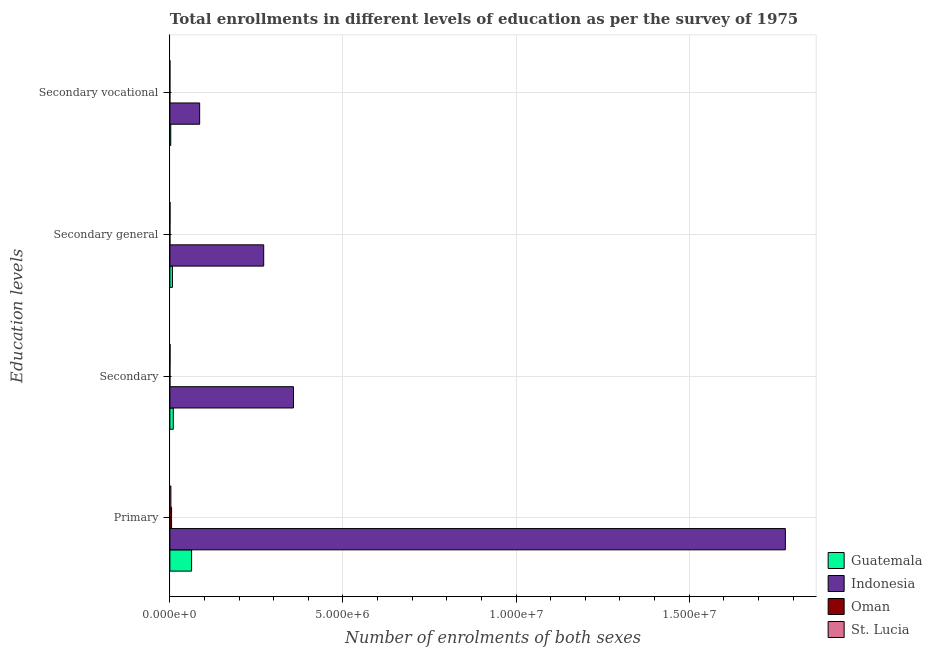How many different coloured bars are there?
Keep it short and to the point. 4. How many groups of bars are there?
Provide a succinct answer. 4. Are the number of bars per tick equal to the number of legend labels?
Make the answer very short. Yes. Are the number of bars on each tick of the Y-axis equal?
Your response must be concise. Yes. How many bars are there on the 1st tick from the top?
Your response must be concise. 4. What is the label of the 1st group of bars from the top?
Your answer should be very brief. Secondary vocational. What is the number of enrolments in secondary education in St. Lucia?
Provide a succinct answer. 4579. Across all countries, what is the maximum number of enrolments in secondary general education?
Give a very brief answer. 2.71e+06. Across all countries, what is the minimum number of enrolments in secondary vocational education?
Provide a short and direct response. 70. In which country was the number of enrolments in primary education maximum?
Your response must be concise. Indonesia. In which country was the number of enrolments in secondary vocational education minimum?
Offer a terse response. Oman. What is the total number of enrolments in primary education in the graph?
Provide a succinct answer. 1.85e+07. What is the difference between the number of enrolments in secondary general education in St. Lucia and that in Indonesia?
Keep it short and to the point. -2.71e+06. What is the difference between the number of enrolments in secondary education in Oman and the number of enrolments in secondary general education in Indonesia?
Give a very brief answer. -2.71e+06. What is the average number of enrolments in secondary education per country?
Give a very brief answer. 9.19e+05. What is the difference between the number of enrolments in secondary education and number of enrolments in secondary general education in Oman?
Provide a short and direct response. 70. In how many countries, is the number of enrolments in secondary vocational education greater than 15000000 ?
Ensure brevity in your answer.  0. What is the ratio of the number of enrolments in secondary education in Indonesia to that in Guatemala?
Ensure brevity in your answer.  35.98. What is the difference between the highest and the second highest number of enrolments in secondary vocational education?
Your response must be concise. 8.35e+05. What is the difference between the highest and the lowest number of enrolments in secondary vocational education?
Offer a terse response. 8.60e+05. In how many countries, is the number of enrolments in secondary education greater than the average number of enrolments in secondary education taken over all countries?
Give a very brief answer. 1. What does the 2nd bar from the top in Secondary vocational represents?
Offer a terse response. Oman. What does the 1st bar from the bottom in Secondary general represents?
Your response must be concise. Guatemala. How many bars are there?
Offer a very short reply. 16. Are all the bars in the graph horizontal?
Ensure brevity in your answer.  Yes. How many countries are there in the graph?
Keep it short and to the point. 4. What is the difference between two consecutive major ticks on the X-axis?
Ensure brevity in your answer.  5.00e+06. Are the values on the major ticks of X-axis written in scientific E-notation?
Provide a short and direct response. Yes. Does the graph contain any zero values?
Offer a very short reply. No. Does the graph contain grids?
Keep it short and to the point. Yes. Where does the legend appear in the graph?
Your answer should be very brief. Bottom right. How are the legend labels stacked?
Provide a succinct answer. Vertical. What is the title of the graph?
Offer a very short reply. Total enrollments in different levels of education as per the survey of 1975. What is the label or title of the X-axis?
Make the answer very short. Number of enrolments of both sexes. What is the label or title of the Y-axis?
Make the answer very short. Education levels. What is the Number of enrolments of both sexes of Guatemala in Primary?
Your answer should be very brief. 6.27e+05. What is the Number of enrolments of both sexes in Indonesia in Primary?
Your answer should be very brief. 1.78e+07. What is the Number of enrolments of both sexes of Oman in Primary?
Provide a short and direct response. 4.86e+04. What is the Number of enrolments of both sexes of St. Lucia in Primary?
Provide a short and direct response. 2.91e+04. What is the Number of enrolments of both sexes in Guatemala in Secondary?
Your answer should be compact. 9.92e+04. What is the Number of enrolments of both sexes of Indonesia in Secondary?
Give a very brief answer. 3.57e+06. What is the Number of enrolments of both sexes in Oman in Secondary?
Your answer should be compact. 723. What is the Number of enrolments of both sexes of St. Lucia in Secondary?
Keep it short and to the point. 4579. What is the Number of enrolments of both sexes of Guatemala in Secondary general?
Ensure brevity in your answer.  7.39e+04. What is the Number of enrolments of both sexes of Indonesia in Secondary general?
Your answer should be very brief. 2.71e+06. What is the Number of enrolments of both sexes of Oman in Secondary general?
Provide a succinct answer. 653. What is the Number of enrolments of both sexes in St. Lucia in Secondary general?
Your response must be concise. 4181. What is the Number of enrolments of both sexes in Guatemala in Secondary vocational?
Your response must be concise. 2.53e+04. What is the Number of enrolments of both sexes of Indonesia in Secondary vocational?
Provide a succinct answer. 8.60e+05. What is the Number of enrolments of both sexes of St. Lucia in Secondary vocational?
Ensure brevity in your answer.  398. Across all Education levels, what is the maximum Number of enrolments of both sexes of Guatemala?
Offer a very short reply. 6.27e+05. Across all Education levels, what is the maximum Number of enrolments of both sexes of Indonesia?
Ensure brevity in your answer.  1.78e+07. Across all Education levels, what is the maximum Number of enrolments of both sexes in Oman?
Provide a short and direct response. 4.86e+04. Across all Education levels, what is the maximum Number of enrolments of both sexes in St. Lucia?
Your answer should be very brief. 2.91e+04. Across all Education levels, what is the minimum Number of enrolments of both sexes of Guatemala?
Ensure brevity in your answer.  2.53e+04. Across all Education levels, what is the minimum Number of enrolments of both sexes of Indonesia?
Ensure brevity in your answer.  8.60e+05. Across all Education levels, what is the minimum Number of enrolments of both sexes in Oman?
Keep it short and to the point. 70. Across all Education levels, what is the minimum Number of enrolments of both sexes of St. Lucia?
Your answer should be very brief. 398. What is the total Number of enrolments of both sexes of Guatemala in the graph?
Provide a short and direct response. 8.26e+05. What is the total Number of enrolments of both sexes of Indonesia in the graph?
Ensure brevity in your answer.  2.49e+07. What is the total Number of enrolments of both sexes in Oman in the graph?
Make the answer very short. 5.01e+04. What is the total Number of enrolments of both sexes in St. Lucia in the graph?
Give a very brief answer. 3.82e+04. What is the difference between the Number of enrolments of both sexes of Guatemala in Primary and that in Secondary?
Provide a short and direct response. 5.28e+05. What is the difference between the Number of enrolments of both sexes in Indonesia in Primary and that in Secondary?
Ensure brevity in your answer.  1.42e+07. What is the difference between the Number of enrolments of both sexes in Oman in Primary and that in Secondary?
Give a very brief answer. 4.79e+04. What is the difference between the Number of enrolments of both sexes in St. Lucia in Primary and that in Secondary?
Give a very brief answer. 2.45e+04. What is the difference between the Number of enrolments of both sexes of Guatemala in Primary and that in Secondary general?
Make the answer very short. 5.53e+05. What is the difference between the Number of enrolments of both sexes in Indonesia in Primary and that in Secondary general?
Keep it short and to the point. 1.51e+07. What is the difference between the Number of enrolments of both sexes in Oman in Primary and that in Secondary general?
Ensure brevity in your answer.  4.80e+04. What is the difference between the Number of enrolments of both sexes in St. Lucia in Primary and that in Secondary general?
Your answer should be compact. 2.49e+04. What is the difference between the Number of enrolments of both sexes of Guatemala in Primary and that in Secondary vocational?
Give a very brief answer. 6.02e+05. What is the difference between the Number of enrolments of both sexes of Indonesia in Primary and that in Secondary vocational?
Offer a terse response. 1.69e+07. What is the difference between the Number of enrolments of both sexes in Oman in Primary and that in Secondary vocational?
Ensure brevity in your answer.  4.86e+04. What is the difference between the Number of enrolments of both sexes of St. Lucia in Primary and that in Secondary vocational?
Your answer should be compact. 2.87e+04. What is the difference between the Number of enrolments of both sexes in Guatemala in Secondary and that in Secondary general?
Keep it short and to the point. 2.53e+04. What is the difference between the Number of enrolments of both sexes in Indonesia in Secondary and that in Secondary general?
Your answer should be compact. 8.60e+05. What is the difference between the Number of enrolments of both sexes in Oman in Secondary and that in Secondary general?
Your answer should be very brief. 70. What is the difference between the Number of enrolments of both sexes in St. Lucia in Secondary and that in Secondary general?
Offer a very short reply. 398. What is the difference between the Number of enrolments of both sexes in Guatemala in Secondary and that in Secondary vocational?
Your answer should be compact. 7.39e+04. What is the difference between the Number of enrolments of both sexes of Indonesia in Secondary and that in Secondary vocational?
Offer a terse response. 2.71e+06. What is the difference between the Number of enrolments of both sexes of Oman in Secondary and that in Secondary vocational?
Your answer should be very brief. 653. What is the difference between the Number of enrolments of both sexes of St. Lucia in Secondary and that in Secondary vocational?
Provide a succinct answer. 4181. What is the difference between the Number of enrolments of both sexes in Guatemala in Secondary general and that in Secondary vocational?
Provide a short and direct response. 4.87e+04. What is the difference between the Number of enrolments of both sexes of Indonesia in Secondary general and that in Secondary vocational?
Provide a succinct answer. 1.85e+06. What is the difference between the Number of enrolments of both sexes of Oman in Secondary general and that in Secondary vocational?
Offer a terse response. 583. What is the difference between the Number of enrolments of both sexes in St. Lucia in Secondary general and that in Secondary vocational?
Ensure brevity in your answer.  3783. What is the difference between the Number of enrolments of both sexes in Guatemala in Primary and the Number of enrolments of both sexes in Indonesia in Secondary?
Provide a short and direct response. -2.94e+06. What is the difference between the Number of enrolments of both sexes in Guatemala in Primary and the Number of enrolments of both sexes in Oman in Secondary?
Ensure brevity in your answer.  6.26e+05. What is the difference between the Number of enrolments of both sexes of Guatemala in Primary and the Number of enrolments of both sexes of St. Lucia in Secondary?
Keep it short and to the point. 6.23e+05. What is the difference between the Number of enrolments of both sexes of Indonesia in Primary and the Number of enrolments of both sexes of Oman in Secondary?
Your answer should be compact. 1.78e+07. What is the difference between the Number of enrolments of both sexes of Indonesia in Primary and the Number of enrolments of both sexes of St. Lucia in Secondary?
Ensure brevity in your answer.  1.78e+07. What is the difference between the Number of enrolments of both sexes of Oman in Primary and the Number of enrolments of both sexes of St. Lucia in Secondary?
Ensure brevity in your answer.  4.41e+04. What is the difference between the Number of enrolments of both sexes of Guatemala in Primary and the Number of enrolments of both sexes of Indonesia in Secondary general?
Make the answer very short. -2.08e+06. What is the difference between the Number of enrolments of both sexes of Guatemala in Primary and the Number of enrolments of both sexes of Oman in Secondary general?
Ensure brevity in your answer.  6.26e+05. What is the difference between the Number of enrolments of both sexes of Guatemala in Primary and the Number of enrolments of both sexes of St. Lucia in Secondary general?
Your answer should be compact. 6.23e+05. What is the difference between the Number of enrolments of both sexes in Indonesia in Primary and the Number of enrolments of both sexes in Oman in Secondary general?
Your answer should be compact. 1.78e+07. What is the difference between the Number of enrolments of both sexes in Indonesia in Primary and the Number of enrolments of both sexes in St. Lucia in Secondary general?
Keep it short and to the point. 1.78e+07. What is the difference between the Number of enrolments of both sexes of Oman in Primary and the Number of enrolments of both sexes of St. Lucia in Secondary general?
Provide a succinct answer. 4.45e+04. What is the difference between the Number of enrolments of both sexes of Guatemala in Primary and the Number of enrolments of both sexes of Indonesia in Secondary vocational?
Give a very brief answer. -2.33e+05. What is the difference between the Number of enrolments of both sexes of Guatemala in Primary and the Number of enrolments of both sexes of Oman in Secondary vocational?
Provide a short and direct response. 6.27e+05. What is the difference between the Number of enrolments of both sexes of Guatemala in Primary and the Number of enrolments of both sexes of St. Lucia in Secondary vocational?
Ensure brevity in your answer.  6.27e+05. What is the difference between the Number of enrolments of both sexes of Indonesia in Primary and the Number of enrolments of both sexes of Oman in Secondary vocational?
Your answer should be very brief. 1.78e+07. What is the difference between the Number of enrolments of both sexes of Indonesia in Primary and the Number of enrolments of both sexes of St. Lucia in Secondary vocational?
Ensure brevity in your answer.  1.78e+07. What is the difference between the Number of enrolments of both sexes of Oman in Primary and the Number of enrolments of both sexes of St. Lucia in Secondary vocational?
Offer a very short reply. 4.83e+04. What is the difference between the Number of enrolments of both sexes of Guatemala in Secondary and the Number of enrolments of both sexes of Indonesia in Secondary general?
Give a very brief answer. -2.61e+06. What is the difference between the Number of enrolments of both sexes in Guatemala in Secondary and the Number of enrolments of both sexes in Oman in Secondary general?
Give a very brief answer. 9.86e+04. What is the difference between the Number of enrolments of both sexes of Guatemala in Secondary and the Number of enrolments of both sexes of St. Lucia in Secondary general?
Offer a terse response. 9.51e+04. What is the difference between the Number of enrolments of both sexes in Indonesia in Secondary and the Number of enrolments of both sexes in Oman in Secondary general?
Your response must be concise. 3.57e+06. What is the difference between the Number of enrolments of both sexes of Indonesia in Secondary and the Number of enrolments of both sexes of St. Lucia in Secondary general?
Ensure brevity in your answer.  3.57e+06. What is the difference between the Number of enrolments of both sexes in Oman in Secondary and the Number of enrolments of both sexes in St. Lucia in Secondary general?
Ensure brevity in your answer.  -3458. What is the difference between the Number of enrolments of both sexes of Guatemala in Secondary and the Number of enrolments of both sexes of Indonesia in Secondary vocational?
Offer a very short reply. -7.61e+05. What is the difference between the Number of enrolments of both sexes of Guatemala in Secondary and the Number of enrolments of both sexes of Oman in Secondary vocational?
Ensure brevity in your answer.  9.92e+04. What is the difference between the Number of enrolments of both sexes of Guatemala in Secondary and the Number of enrolments of both sexes of St. Lucia in Secondary vocational?
Your answer should be compact. 9.88e+04. What is the difference between the Number of enrolments of both sexes of Indonesia in Secondary and the Number of enrolments of both sexes of Oman in Secondary vocational?
Keep it short and to the point. 3.57e+06. What is the difference between the Number of enrolments of both sexes in Indonesia in Secondary and the Number of enrolments of both sexes in St. Lucia in Secondary vocational?
Your response must be concise. 3.57e+06. What is the difference between the Number of enrolments of both sexes in Oman in Secondary and the Number of enrolments of both sexes in St. Lucia in Secondary vocational?
Your answer should be compact. 325. What is the difference between the Number of enrolments of both sexes in Guatemala in Secondary general and the Number of enrolments of both sexes in Indonesia in Secondary vocational?
Your response must be concise. -7.86e+05. What is the difference between the Number of enrolments of both sexes of Guatemala in Secondary general and the Number of enrolments of both sexes of Oman in Secondary vocational?
Your answer should be compact. 7.39e+04. What is the difference between the Number of enrolments of both sexes of Guatemala in Secondary general and the Number of enrolments of both sexes of St. Lucia in Secondary vocational?
Provide a succinct answer. 7.35e+04. What is the difference between the Number of enrolments of both sexes of Indonesia in Secondary general and the Number of enrolments of both sexes of Oman in Secondary vocational?
Provide a succinct answer. 2.71e+06. What is the difference between the Number of enrolments of both sexes of Indonesia in Secondary general and the Number of enrolments of both sexes of St. Lucia in Secondary vocational?
Provide a succinct answer. 2.71e+06. What is the difference between the Number of enrolments of both sexes in Oman in Secondary general and the Number of enrolments of both sexes in St. Lucia in Secondary vocational?
Your response must be concise. 255. What is the average Number of enrolments of both sexes in Guatemala per Education levels?
Give a very brief answer. 2.06e+05. What is the average Number of enrolments of both sexes of Indonesia per Education levels?
Offer a terse response. 6.23e+06. What is the average Number of enrolments of both sexes of Oman per Education levels?
Offer a terse response. 1.25e+04. What is the average Number of enrolments of both sexes of St. Lucia per Education levels?
Provide a short and direct response. 9562. What is the difference between the Number of enrolments of both sexes of Guatemala and Number of enrolments of both sexes of Indonesia in Primary?
Make the answer very short. -1.71e+07. What is the difference between the Number of enrolments of both sexes in Guatemala and Number of enrolments of both sexes in Oman in Primary?
Offer a very short reply. 5.78e+05. What is the difference between the Number of enrolments of both sexes in Guatemala and Number of enrolments of both sexes in St. Lucia in Primary?
Provide a succinct answer. 5.98e+05. What is the difference between the Number of enrolments of both sexes of Indonesia and Number of enrolments of both sexes of Oman in Primary?
Provide a short and direct response. 1.77e+07. What is the difference between the Number of enrolments of both sexes of Indonesia and Number of enrolments of both sexes of St. Lucia in Primary?
Make the answer very short. 1.77e+07. What is the difference between the Number of enrolments of both sexes of Oman and Number of enrolments of both sexes of St. Lucia in Primary?
Give a very brief answer. 1.96e+04. What is the difference between the Number of enrolments of both sexes of Guatemala and Number of enrolments of both sexes of Indonesia in Secondary?
Provide a succinct answer. -3.47e+06. What is the difference between the Number of enrolments of both sexes in Guatemala and Number of enrolments of both sexes in Oman in Secondary?
Your answer should be very brief. 9.85e+04. What is the difference between the Number of enrolments of both sexes in Guatemala and Number of enrolments of both sexes in St. Lucia in Secondary?
Offer a very short reply. 9.47e+04. What is the difference between the Number of enrolments of both sexes in Indonesia and Number of enrolments of both sexes in Oman in Secondary?
Your response must be concise. 3.57e+06. What is the difference between the Number of enrolments of both sexes of Indonesia and Number of enrolments of both sexes of St. Lucia in Secondary?
Offer a very short reply. 3.57e+06. What is the difference between the Number of enrolments of both sexes in Oman and Number of enrolments of both sexes in St. Lucia in Secondary?
Ensure brevity in your answer.  -3856. What is the difference between the Number of enrolments of both sexes in Guatemala and Number of enrolments of both sexes in Indonesia in Secondary general?
Offer a very short reply. -2.64e+06. What is the difference between the Number of enrolments of both sexes in Guatemala and Number of enrolments of both sexes in Oman in Secondary general?
Ensure brevity in your answer.  7.33e+04. What is the difference between the Number of enrolments of both sexes of Guatemala and Number of enrolments of both sexes of St. Lucia in Secondary general?
Your answer should be compact. 6.98e+04. What is the difference between the Number of enrolments of both sexes of Indonesia and Number of enrolments of both sexes of Oman in Secondary general?
Make the answer very short. 2.71e+06. What is the difference between the Number of enrolments of both sexes of Indonesia and Number of enrolments of both sexes of St. Lucia in Secondary general?
Your response must be concise. 2.71e+06. What is the difference between the Number of enrolments of both sexes in Oman and Number of enrolments of both sexes in St. Lucia in Secondary general?
Offer a terse response. -3528. What is the difference between the Number of enrolments of both sexes in Guatemala and Number of enrolments of both sexes in Indonesia in Secondary vocational?
Provide a succinct answer. -8.35e+05. What is the difference between the Number of enrolments of both sexes of Guatemala and Number of enrolments of both sexes of Oman in Secondary vocational?
Offer a terse response. 2.52e+04. What is the difference between the Number of enrolments of both sexes in Guatemala and Number of enrolments of both sexes in St. Lucia in Secondary vocational?
Offer a terse response. 2.49e+04. What is the difference between the Number of enrolments of both sexes in Indonesia and Number of enrolments of both sexes in Oman in Secondary vocational?
Provide a succinct answer. 8.60e+05. What is the difference between the Number of enrolments of both sexes in Indonesia and Number of enrolments of both sexes in St. Lucia in Secondary vocational?
Your response must be concise. 8.60e+05. What is the difference between the Number of enrolments of both sexes of Oman and Number of enrolments of both sexes of St. Lucia in Secondary vocational?
Your answer should be very brief. -328. What is the ratio of the Number of enrolments of both sexes of Guatemala in Primary to that in Secondary?
Offer a terse response. 6.32. What is the ratio of the Number of enrolments of both sexes of Indonesia in Primary to that in Secondary?
Give a very brief answer. 4.98. What is the ratio of the Number of enrolments of both sexes in Oman in Primary to that in Secondary?
Provide a succinct answer. 67.29. What is the ratio of the Number of enrolments of both sexes in St. Lucia in Primary to that in Secondary?
Offer a terse response. 6.35. What is the ratio of the Number of enrolments of both sexes of Guatemala in Primary to that in Secondary general?
Your answer should be compact. 8.48. What is the ratio of the Number of enrolments of both sexes in Indonesia in Primary to that in Secondary general?
Make the answer very short. 6.56. What is the ratio of the Number of enrolments of both sexes in Oman in Primary to that in Secondary general?
Offer a very short reply. 74.5. What is the ratio of the Number of enrolments of both sexes of St. Lucia in Primary to that in Secondary general?
Provide a short and direct response. 6.96. What is the ratio of the Number of enrolments of both sexes in Guatemala in Primary to that in Secondary vocational?
Your answer should be compact. 24.8. What is the ratio of the Number of enrolments of both sexes of Indonesia in Primary to that in Secondary vocational?
Provide a short and direct response. 20.67. What is the ratio of the Number of enrolments of both sexes of Oman in Primary to that in Secondary vocational?
Provide a short and direct response. 694.99. What is the ratio of the Number of enrolments of both sexes of St. Lucia in Primary to that in Secondary vocational?
Your answer should be very brief. 73.09. What is the ratio of the Number of enrolments of both sexes of Guatemala in Secondary to that in Secondary general?
Keep it short and to the point. 1.34. What is the ratio of the Number of enrolments of both sexes in Indonesia in Secondary to that in Secondary general?
Give a very brief answer. 1.32. What is the ratio of the Number of enrolments of both sexes in Oman in Secondary to that in Secondary general?
Your answer should be compact. 1.11. What is the ratio of the Number of enrolments of both sexes in St. Lucia in Secondary to that in Secondary general?
Your answer should be very brief. 1.1. What is the ratio of the Number of enrolments of both sexes in Guatemala in Secondary to that in Secondary vocational?
Give a very brief answer. 3.92. What is the ratio of the Number of enrolments of both sexes in Indonesia in Secondary to that in Secondary vocational?
Offer a terse response. 4.15. What is the ratio of the Number of enrolments of both sexes in Oman in Secondary to that in Secondary vocational?
Your answer should be compact. 10.33. What is the ratio of the Number of enrolments of both sexes of St. Lucia in Secondary to that in Secondary vocational?
Offer a terse response. 11.51. What is the ratio of the Number of enrolments of both sexes in Guatemala in Secondary general to that in Secondary vocational?
Ensure brevity in your answer.  2.92. What is the ratio of the Number of enrolments of both sexes in Indonesia in Secondary general to that in Secondary vocational?
Offer a very short reply. 3.15. What is the ratio of the Number of enrolments of both sexes of Oman in Secondary general to that in Secondary vocational?
Your answer should be compact. 9.33. What is the ratio of the Number of enrolments of both sexes of St. Lucia in Secondary general to that in Secondary vocational?
Give a very brief answer. 10.51. What is the difference between the highest and the second highest Number of enrolments of both sexes in Guatemala?
Your answer should be compact. 5.28e+05. What is the difference between the highest and the second highest Number of enrolments of both sexes of Indonesia?
Offer a terse response. 1.42e+07. What is the difference between the highest and the second highest Number of enrolments of both sexes of Oman?
Provide a succinct answer. 4.79e+04. What is the difference between the highest and the second highest Number of enrolments of both sexes in St. Lucia?
Ensure brevity in your answer.  2.45e+04. What is the difference between the highest and the lowest Number of enrolments of both sexes of Guatemala?
Ensure brevity in your answer.  6.02e+05. What is the difference between the highest and the lowest Number of enrolments of both sexes of Indonesia?
Make the answer very short. 1.69e+07. What is the difference between the highest and the lowest Number of enrolments of both sexes of Oman?
Make the answer very short. 4.86e+04. What is the difference between the highest and the lowest Number of enrolments of both sexes in St. Lucia?
Your answer should be very brief. 2.87e+04. 